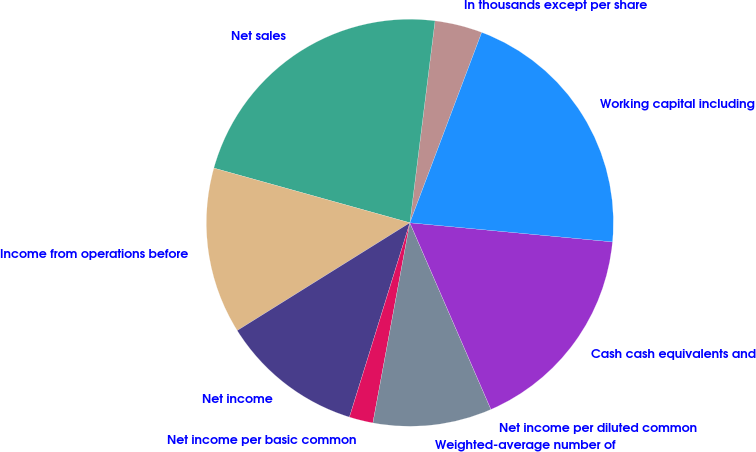Convert chart to OTSL. <chart><loc_0><loc_0><loc_500><loc_500><pie_chart><fcel>In thousands except per share<fcel>Net sales<fcel>Income from operations before<fcel>Net income<fcel>Net income per basic common<fcel>Weighted-average number of<fcel>Net income per diluted common<fcel>Cash cash equivalents and<fcel>Working capital including<nl><fcel>3.77%<fcel>22.64%<fcel>13.21%<fcel>11.32%<fcel>1.89%<fcel>9.43%<fcel>0.0%<fcel>16.98%<fcel>20.75%<nl></chart> 